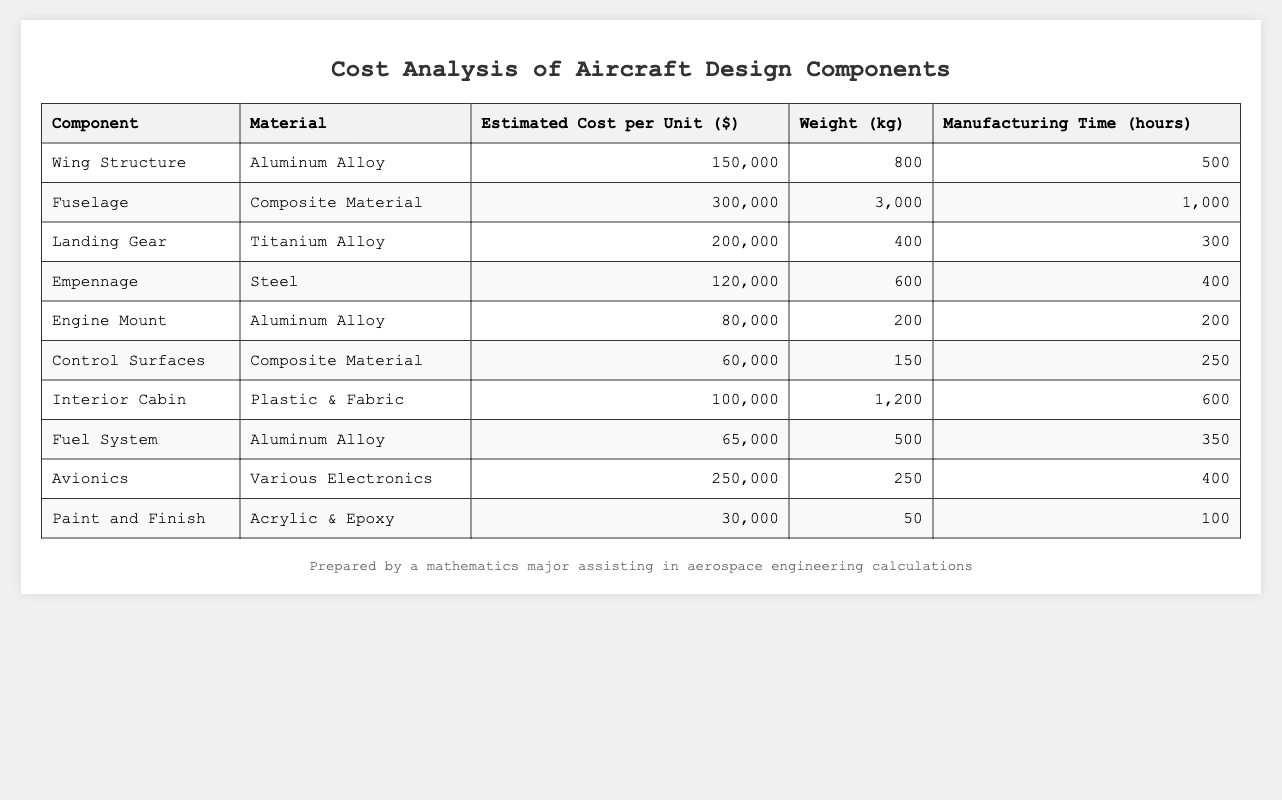What is the estimated cost per unit of the Wing Structure? The table states that the estimated cost per unit of the Wing Structure is listed directly under the "Estimated Cost per Unit" column. The value is 150,000 dollars.
Answer: 150,000 Which component has the highest estimated cost per unit? By comparing the values in the "Estimated Cost per Unit" column, the Fuselage has the highest cost at 300,000 dollars, compared to other components.
Answer: Fuselage What is the total weight of the Fuel System and the Control Surfaces? To find the total weight, add the weight of the Fuel System (500 kg) and the Control Surfaces (150 kg). The total calculation is 500 + 150 = 650 kg.
Answer: 650 kg How many hours are required to manufacture all the components combined? To find total manufacturing time, sum the hours from each component: 500 + 1000 + 300 + 400 + 200 + 250 + 600 + 350 + 400 + 100 = 3200 hours.
Answer: 3200 hours Is the material of the Landing Gear a Composite Material? Looking at the "Material" column for Landing Gear, it shows Titanium Alloy, which is not Composite Material. Therefore, the answer is no.
Answer: No What is the average estimated cost per unit of all components? First, sum the estimated costs: 150000 + 300000 + 200000 + 120000 + 80000 + 60000 + 100000 + 65000 + 250000 + 30000 = 1,310,000. Then divide by the number of components (10): 1,310,000 / 10 = 131,000.
Answer: 131,000 Which component weighs the least, and what is its weight? By examining the "Weight" column, the Paint and Finish component is the lightest at 50 kg.
Answer: Paint and Finish, 50 kg What is the difference in estimated cost between the Fuselage and the Engine Mount? Subtract the estimated cost of the Engine Mount (80,000) from that of the Fuselage (300,000): 300,000 - 80,000 = 220,000 dollars difference.
Answer: 220,000 If you were to compare the manufacturing time of the Empennage and the Landing Gear, which component takes longer to manufacture? The Empennage takes 400 hours while the Landing Gear takes 300 hours. Since 400 is greater than 300, Empennage takes longer.
Answer: Empennage What is the total cost of all components made of Aluminum Alloy? The total cost includes the Wing Structure (150,000), Engine Mount (80,000), and Fuel System (65,000). Summing these gives: 150,000 + 80,000 + 65,000 = 295,000 dollars.
Answer: 295,000 